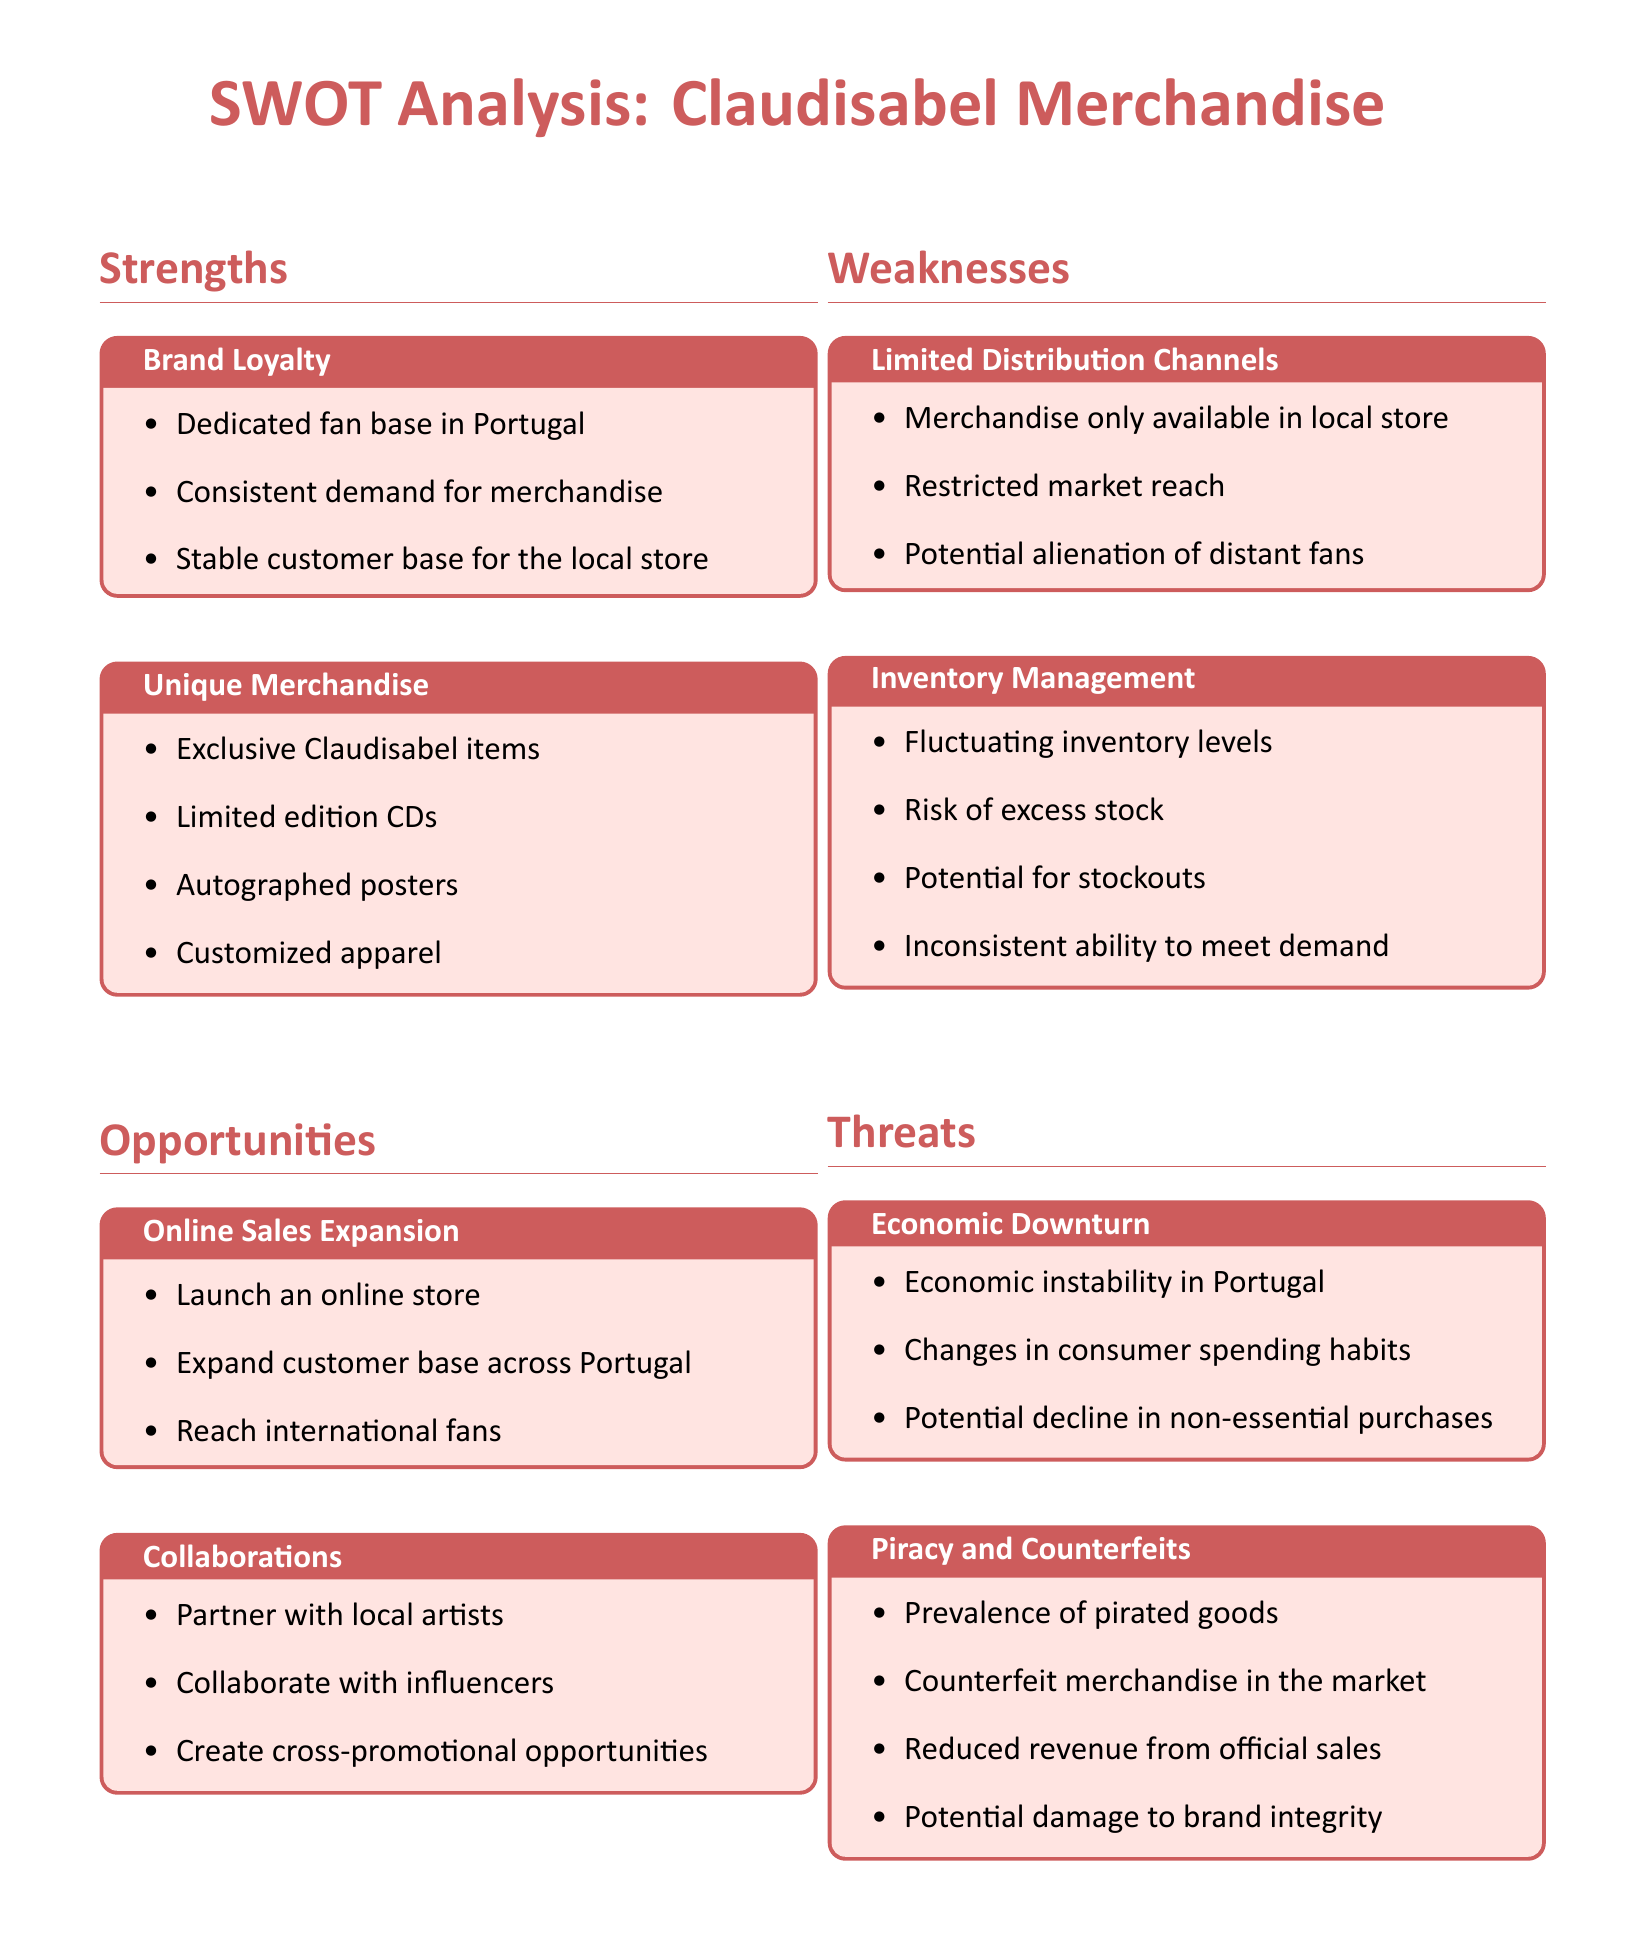What is a key strength of Claudisabel merchandise? A key strength is brand loyalty, which includes a dedicated fan base in Portugal.
Answer: Brand loyalty What type of merchandise is highlighted as unique? Unique merchandise includes exclusive Claudisabel items such as limited edition CDs.
Answer: Unique merchandise What opportunity involves expanding online presence? The opportunity involving online presence is online sales expansion, which includes launching an online store.
Answer: Online sales expansion What is a major weakness regarding distribution? A major weakness is limited distribution channels, as merchandise is only available in the local store.
Answer: Limited distribution channels What economic threat is mentioned? An economic threat mentioned is economic downturn, which refers to instability in Portugal.
Answer: Economic downturn How many weaknesses are noted in the analysis? The analysis notes two weaknesses, limited distribution channels and inventory management.
Answer: Two weaknesses Which threat relates to counterfeit merchandise? The threat related to counterfeit merchandise includes piracy and counterfeits impacting revenue.
Answer: Piracy and counterfeits In what way does the document suggest collaborations as an opportunity? Collaborations as an opportunity include partnering with local artists and influencers.
Answer: Partnering with local artists and influencers 